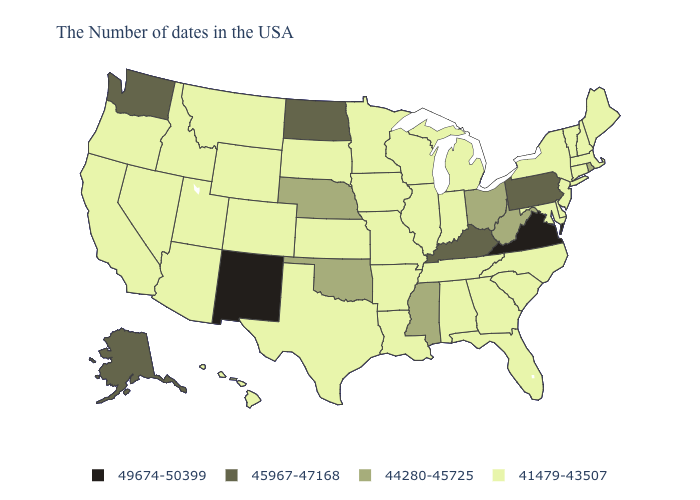Does North Carolina have the highest value in the USA?
Quick response, please. No. Name the states that have a value in the range 41479-43507?
Quick response, please. Maine, Massachusetts, New Hampshire, Vermont, Connecticut, New York, New Jersey, Delaware, Maryland, North Carolina, South Carolina, Florida, Georgia, Michigan, Indiana, Alabama, Tennessee, Wisconsin, Illinois, Louisiana, Missouri, Arkansas, Minnesota, Iowa, Kansas, Texas, South Dakota, Wyoming, Colorado, Utah, Montana, Arizona, Idaho, Nevada, California, Oregon, Hawaii. Name the states that have a value in the range 41479-43507?
Concise answer only. Maine, Massachusetts, New Hampshire, Vermont, Connecticut, New York, New Jersey, Delaware, Maryland, North Carolina, South Carolina, Florida, Georgia, Michigan, Indiana, Alabama, Tennessee, Wisconsin, Illinois, Louisiana, Missouri, Arkansas, Minnesota, Iowa, Kansas, Texas, South Dakota, Wyoming, Colorado, Utah, Montana, Arizona, Idaho, Nevada, California, Oregon, Hawaii. What is the highest value in the South ?
Give a very brief answer. 49674-50399. Does Wisconsin have a higher value than Massachusetts?
Be succinct. No. What is the value of Illinois?
Keep it brief. 41479-43507. Which states hav the highest value in the South?
Quick response, please. Virginia. Is the legend a continuous bar?
Quick response, please. No. Does Hawaii have the same value as Maryland?
Write a very short answer. Yes. Name the states that have a value in the range 41479-43507?
Quick response, please. Maine, Massachusetts, New Hampshire, Vermont, Connecticut, New York, New Jersey, Delaware, Maryland, North Carolina, South Carolina, Florida, Georgia, Michigan, Indiana, Alabama, Tennessee, Wisconsin, Illinois, Louisiana, Missouri, Arkansas, Minnesota, Iowa, Kansas, Texas, South Dakota, Wyoming, Colorado, Utah, Montana, Arizona, Idaho, Nevada, California, Oregon, Hawaii. What is the lowest value in the USA?
Answer briefly. 41479-43507. Which states have the highest value in the USA?
Be succinct. Virginia, New Mexico. Name the states that have a value in the range 45967-47168?
Short answer required. Pennsylvania, Kentucky, North Dakota, Washington, Alaska. What is the value of Idaho?
Be succinct. 41479-43507. Among the states that border Oklahoma , which have the highest value?
Concise answer only. New Mexico. 